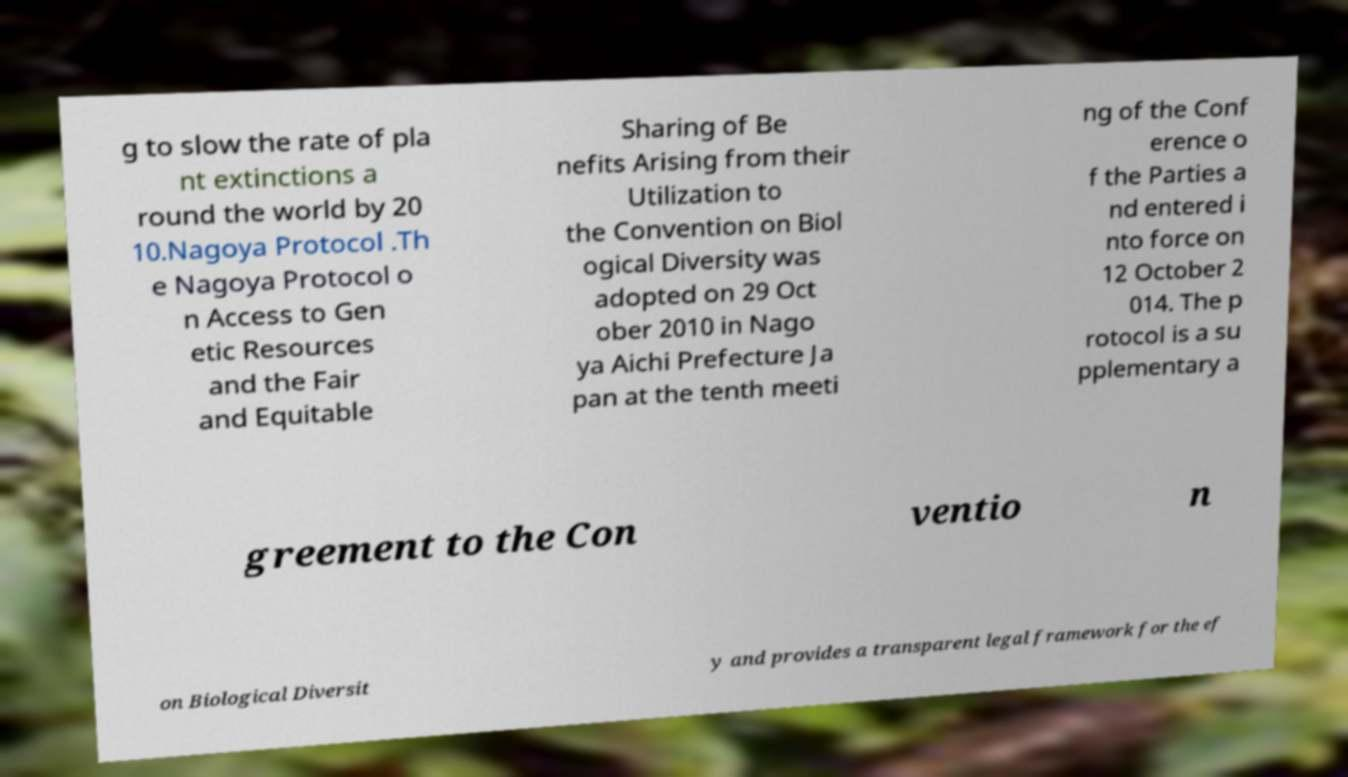Could you extract and type out the text from this image? g to slow the rate of pla nt extinctions a round the world by 20 10.Nagoya Protocol .Th e Nagoya Protocol o n Access to Gen etic Resources and the Fair and Equitable Sharing of Be nefits Arising from their Utilization to the Convention on Biol ogical Diversity was adopted on 29 Oct ober 2010 in Nago ya Aichi Prefecture Ja pan at the tenth meeti ng of the Conf erence o f the Parties a nd entered i nto force on 12 October 2 014. The p rotocol is a su pplementary a greement to the Con ventio n on Biological Diversit y and provides a transparent legal framework for the ef 